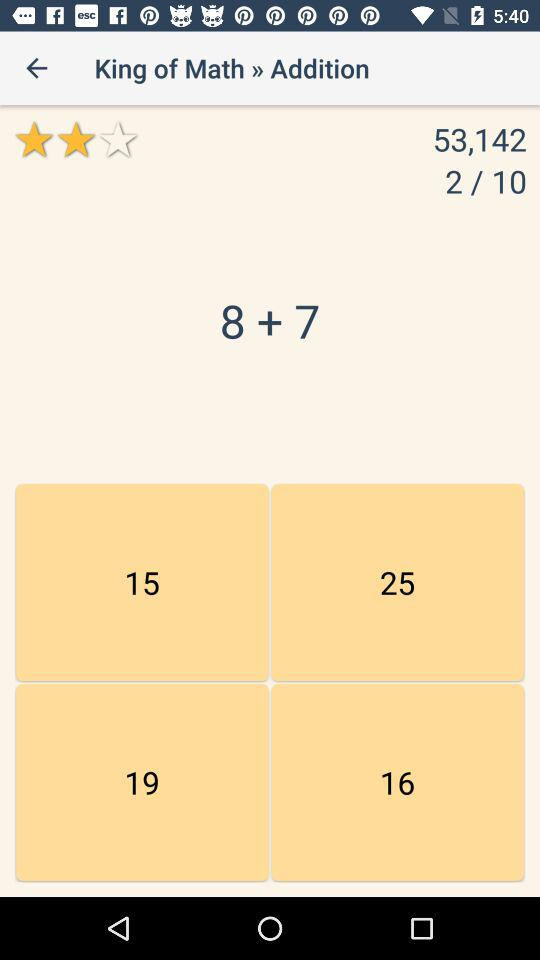What is the sum of the two numbers in the equation?
Answer the question using a single word or phrase. 15 